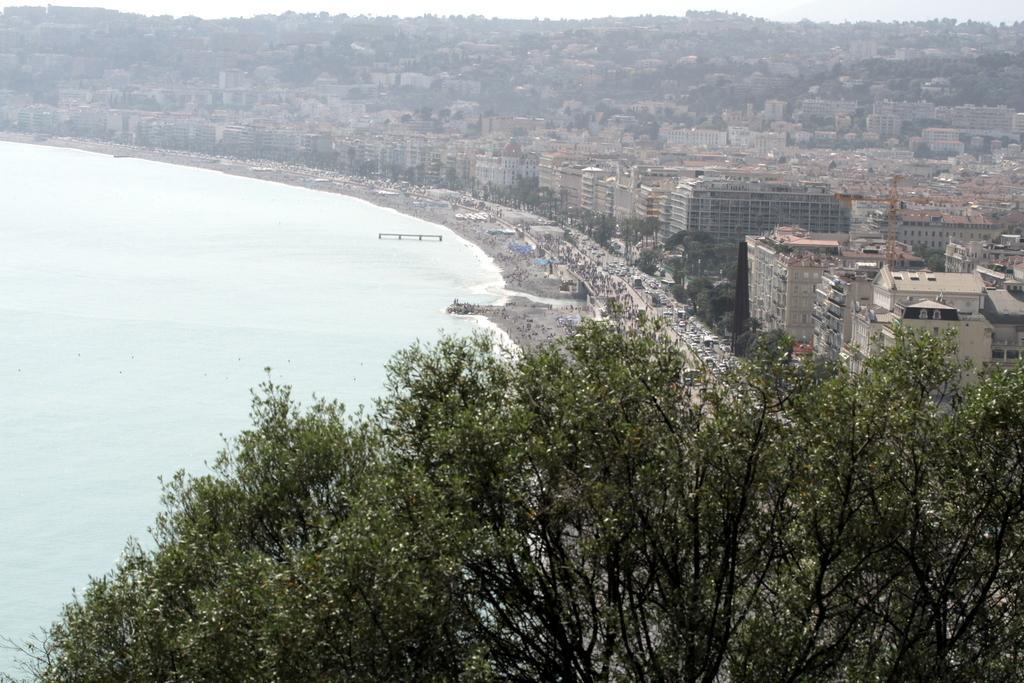In one or two sentences, can you explain what this image depicts? This is an aerial view, we can see some trees, there is water, we can see some buildings, at the top there is a sky. 